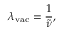Convert formula to latex. <formula><loc_0><loc_0><loc_500><loc_500>\lambda _ { v a c } = { \frac { 1 } { \tilde { \nu } } } ,</formula> 